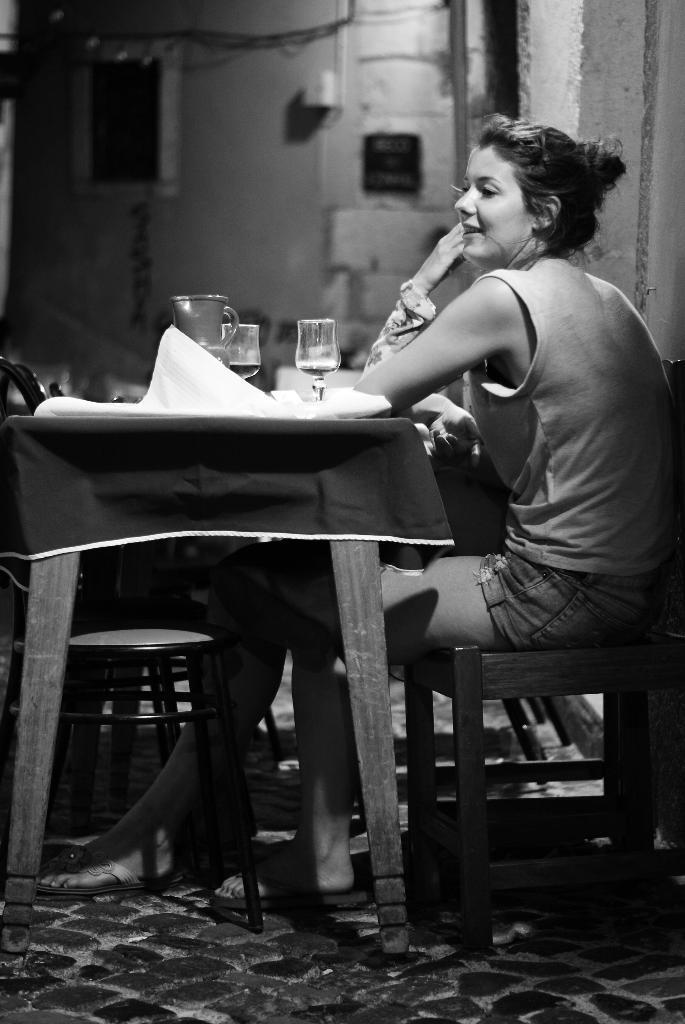In one or two sentences, can you explain what this image depicts? This is the picture of a lady who is sitting on the stool in front of the table on which there are some glasses, jars and also there are some chairs. 